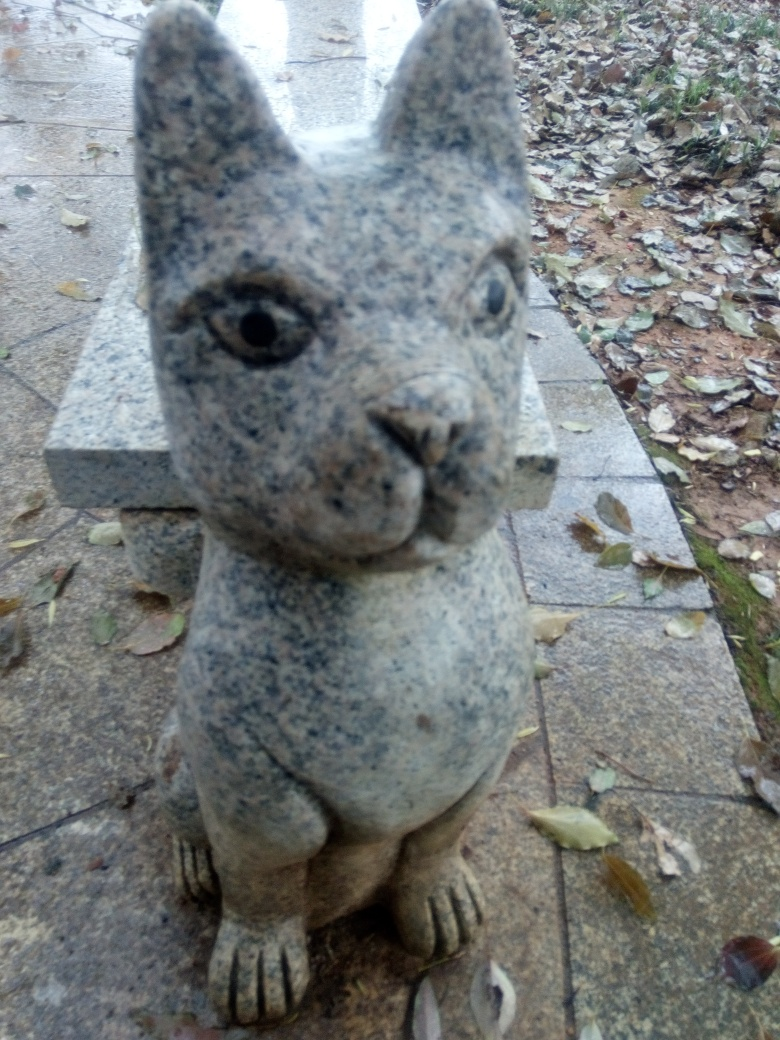How could this image's composition be improved? Improving this image could involve several steps: ensuring the statue is in sharp focus, adjusting the angle to avoid the tilt, and possibly repositioning the object or the camera to enhance the background, framing the sculpture with more visually appealing elements. Moreover, taking the photo during a time of day with better lighting, like the golden hour, could add warmth and depth to the image. 